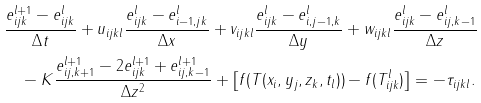Convert formula to latex. <formula><loc_0><loc_0><loc_500><loc_500>& \frac { e _ { i j k } ^ { l + 1 } - e _ { i j k } ^ { l } } { \Delta t } + u _ { i j k l } \frac { e _ { i j k } ^ { l } - e _ { i - 1 , j k } ^ { l } } { \Delta x } + v _ { i j k l } \frac { e _ { i j k } ^ { l } - e _ { i , j - 1 , k } ^ { l } } { \Delta y } + w _ { i j k l } \frac { e _ { i j k } ^ { l } - e _ { i j , k - 1 } ^ { l } } { \Delta z } \\ & \quad - K \frac { e _ { i j , k + 1 } ^ { l + 1 } - 2 e _ { i j k } ^ { l + 1 } + e _ { i j , k - 1 } ^ { l + 1 } } { \Delta z ^ { 2 } } + \left [ f ( T ( x _ { i } , y _ { j } , z _ { k } , t _ { l } ) ) - f ( T _ { i j k } ^ { l } ) \right ] = - \tau _ { i j k l } .</formula> 